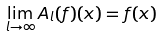<formula> <loc_0><loc_0><loc_500><loc_500>\lim _ { l \to \infty } A _ { l } ( f ) ( x ) = f ( x )</formula> 